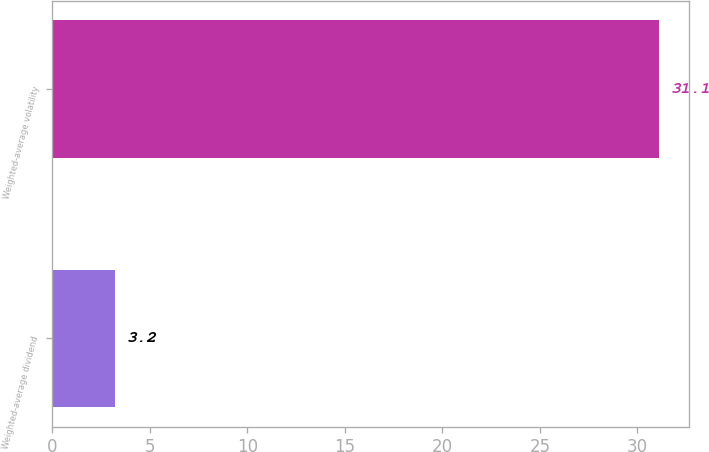<chart> <loc_0><loc_0><loc_500><loc_500><bar_chart><fcel>Weighted-average dividend<fcel>Weighted-average volatility<nl><fcel>3.2<fcel>31.1<nl></chart> 